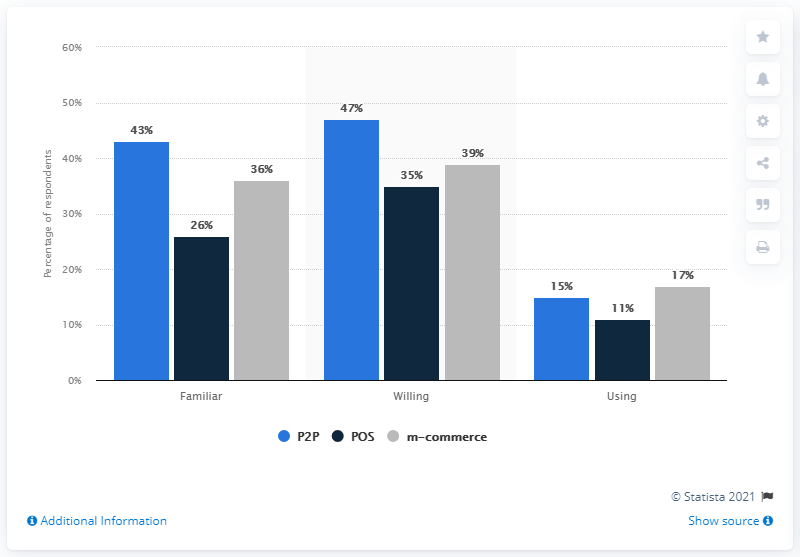Point out several critical features in this image. According to a recent survey, 43% of people are currently using mobile payment methods. The light blue color indicates peer-to-peer (P2P) activity. 